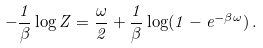<formula> <loc_0><loc_0><loc_500><loc_500>- \frac { 1 } { \beta } \log Z = \frac { \omega } { 2 } + \frac { 1 } { \beta } \log ( 1 - e ^ { - \beta \omega } ) \, .</formula> 